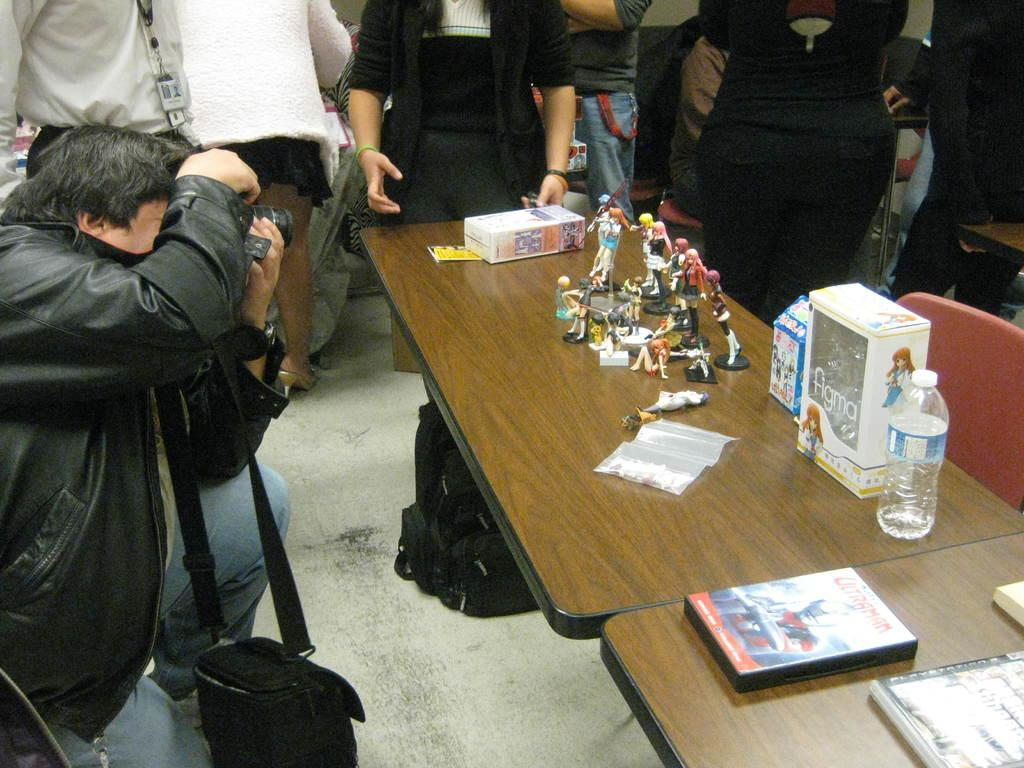What is happening with the group of persons in the image? The group of persons is standing around a table. Can you describe the man on the left side of the image? The man on the left side of the image is holding a camera. What items can be seen on the table in the image? There are toys, a box, a book, paper, and a water bottle on the table. Are there any fairies visible in the image? No, there are no fairies present in the image. What is the tendency of the passenger in the image? There is no passenger mentioned in the image, so it is not possible to determine any tendencies. 